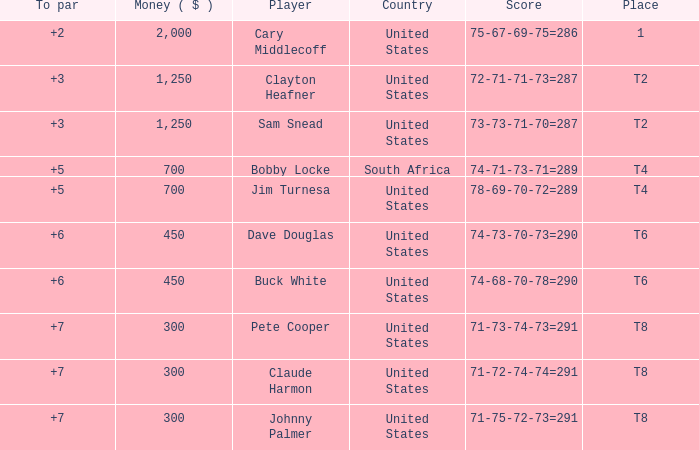What is the Johnny Palmer with a To larger than 6 Money sum? 300.0. 